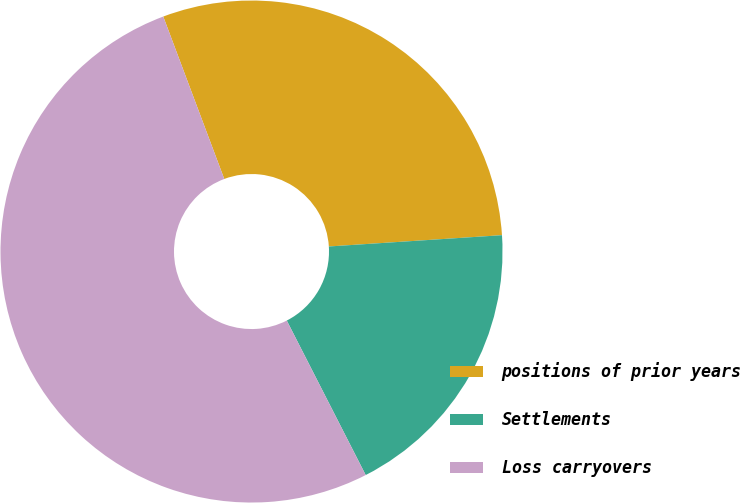Convert chart. <chart><loc_0><loc_0><loc_500><loc_500><pie_chart><fcel>positions of prior years<fcel>Settlements<fcel>Loss carryovers<nl><fcel>29.68%<fcel>18.52%<fcel>51.8%<nl></chart> 